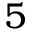Convert formula to latex. <formula><loc_0><loc_0><loc_500><loc_500>5</formula> 